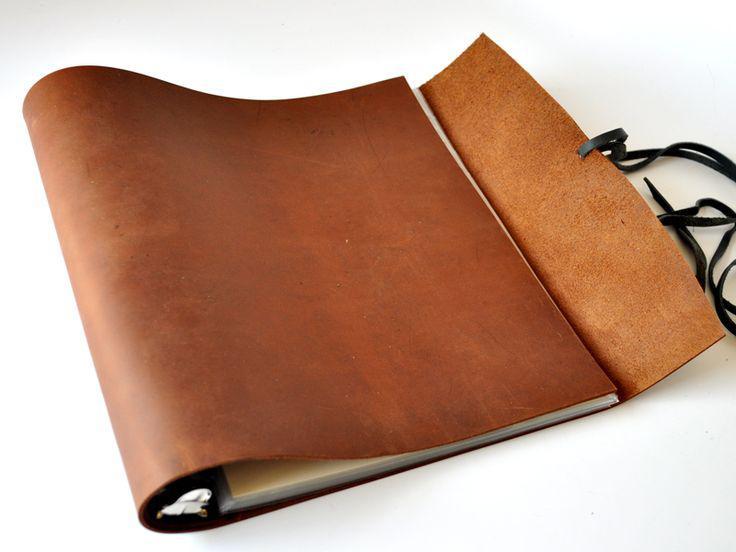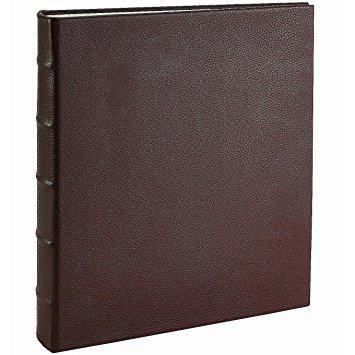The first image is the image on the left, the second image is the image on the right. Considering the images on both sides, is "Two leather binders are shown, one closed and the other open flat, showing its interior layout." valid? Answer yes or no. No. The first image is the image on the left, the second image is the image on the right. For the images shown, is this caption "An image shows a single upright binder, which is dark burgundy-brownish in color." true? Answer yes or no. Yes. 